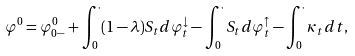Convert formula to latex. <formula><loc_0><loc_0><loc_500><loc_500>\varphi ^ { 0 } = \varphi ^ { 0 } _ { 0 - } + \int _ { 0 } ^ { \cdot } ( 1 - \lambda ) S _ { t } d \varphi ^ { \downarrow } _ { t } - \int _ { 0 } ^ { \cdot } S _ { t } d \varphi ^ { \uparrow } _ { t } - \int _ { 0 } ^ { \cdot } \kappa _ { t } d t ,</formula> 